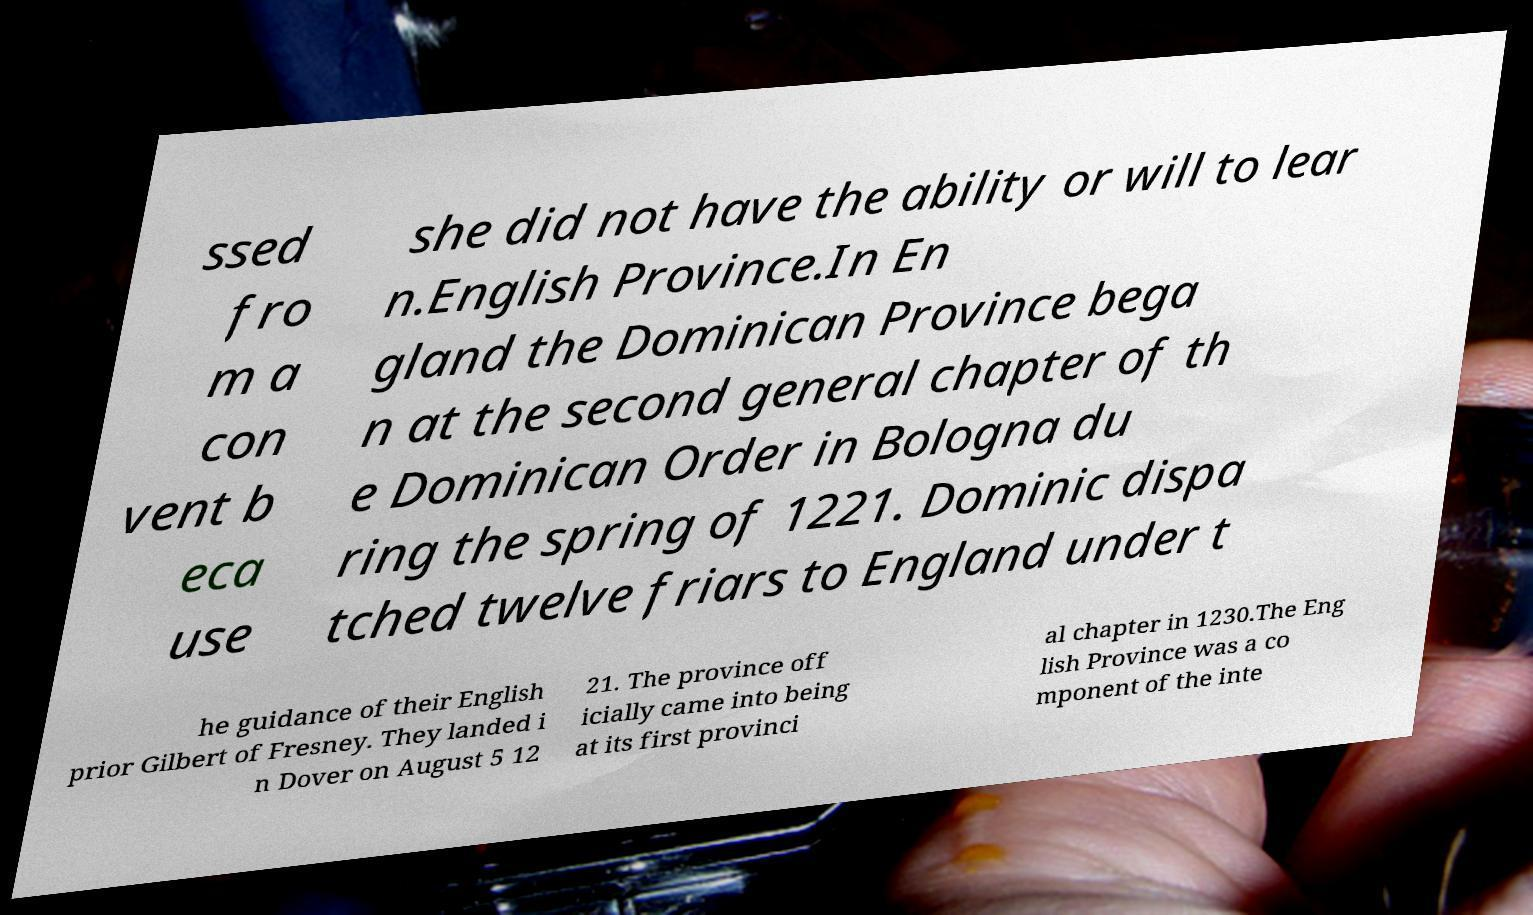Could you assist in decoding the text presented in this image and type it out clearly? ssed fro m a con vent b eca use she did not have the ability or will to lear n.English Province.In En gland the Dominican Province bega n at the second general chapter of th e Dominican Order in Bologna du ring the spring of 1221. Dominic dispa tched twelve friars to England under t he guidance of their English prior Gilbert of Fresney. They landed i n Dover on August 5 12 21. The province off icially came into being at its first provinci al chapter in 1230.The Eng lish Province was a co mponent of the inte 